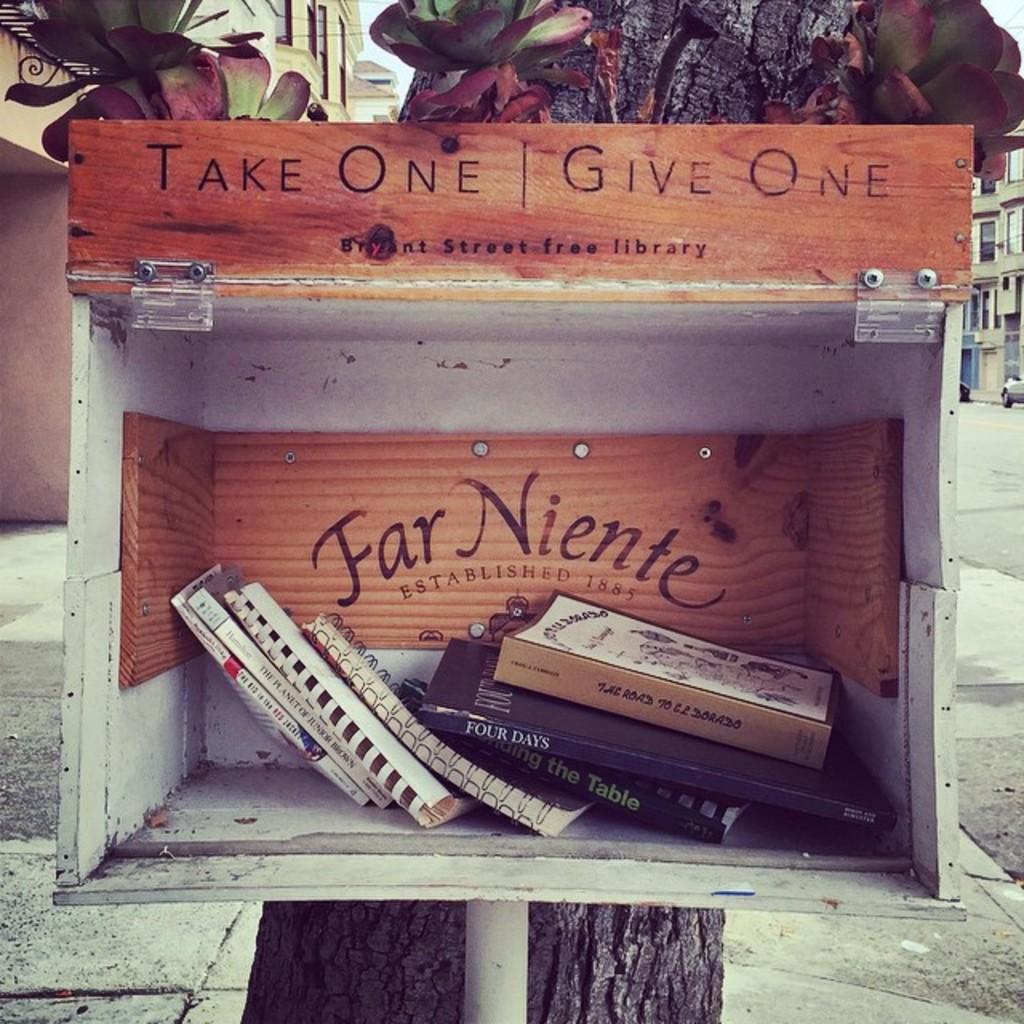Are we allowed to take one?
Provide a succinct answer. Yes. What do you do after you take one?
Make the answer very short. Give one. 